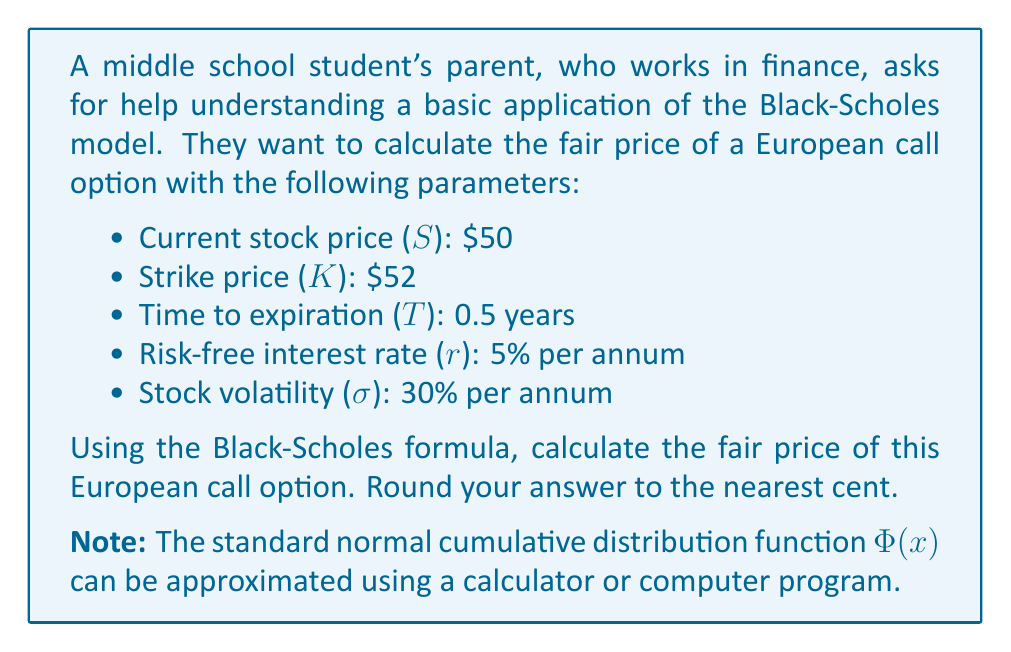Can you answer this question? Let's approach this step-by-step using the Black-Scholes formula for a European call option:

1) The Black-Scholes formula for a call option is:

   $$C = S \cdot \Phi(d_1) - K \cdot e^{-rT} \cdot \Phi(d_2)$$

   Where:
   $$d_1 = \frac{\ln(S/K) + (r + \sigma^2/2)T}{\sigma\sqrt{T}}$$
   $$d_2 = d_1 - \sigma\sqrt{T}$$

2) Let's calculate $d_1$ first:

   $$d_1 = \frac{\ln(50/52) + (0.05 + 0.3^2/2) \cdot 0.5}{0.3\sqrt{0.5}}$$
   $$d_1 = \frac{-0.0392 + (0.05 + 0.045) \cdot 0.5}{0.3\sqrt{0.5}}$$
   $$d_1 = \frac{-0.0392 + 0.0475}{0.2121} = 0.0391$$

3) Now let's calculate $d_2$:

   $$d_2 = d_1 - 0.3\sqrt{0.5} = 0.0391 - 0.2121 = -0.1730$$

4) Next, we need to find $\Phi(d_1)$ and $\Phi(d_2)$. These values can be obtained from a standard normal distribution table or calculator:

   $\Phi(0.0391) \approx 0.5156$
   $\Phi(-0.1730) \approx 0.4313$

5) Now we can plug everything into the Black-Scholes formula:

   $$C = 50 \cdot 0.5156 - 52 \cdot e^{-0.05 \cdot 0.5} \cdot 0.4313$$

6) Simplify:

   $$C = 25.78 - 52 \cdot 0.9753 \cdot 0.4313$$
   $$C = 25.78 - 21.85 = 3.93$$

Therefore, the fair price of the European call option is approximately $3.93.
Answer: $3.93 